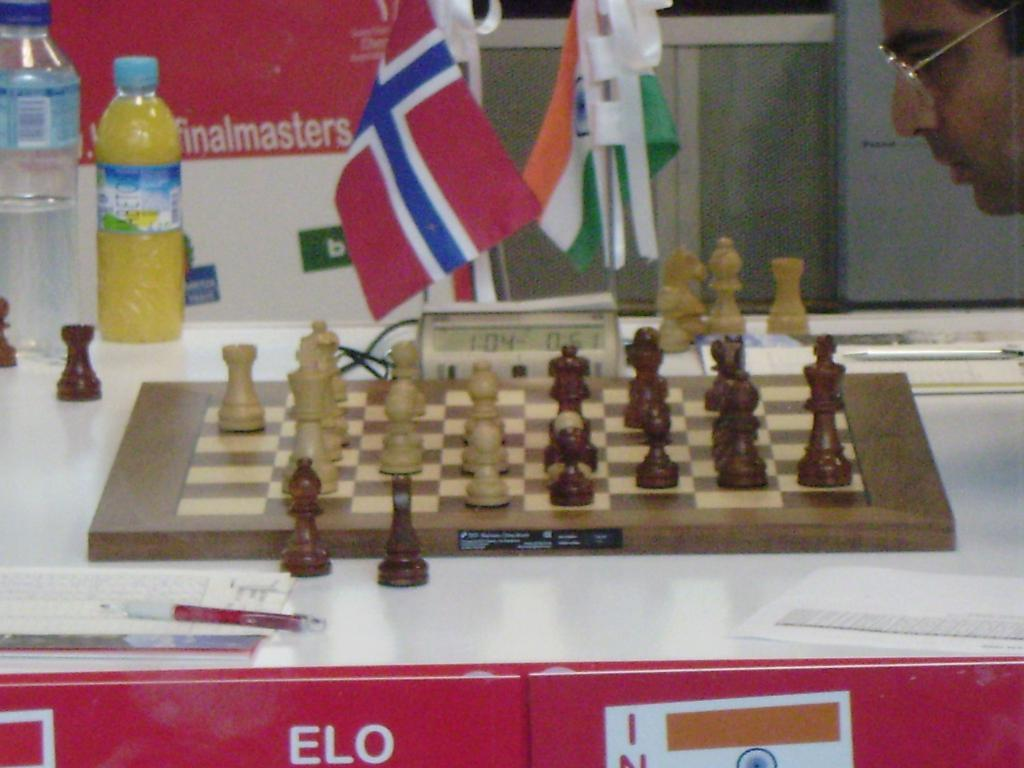<image>
Create a compact narrative representing the image presented. A man is thinking really hard in a Finalmasters chess game. 